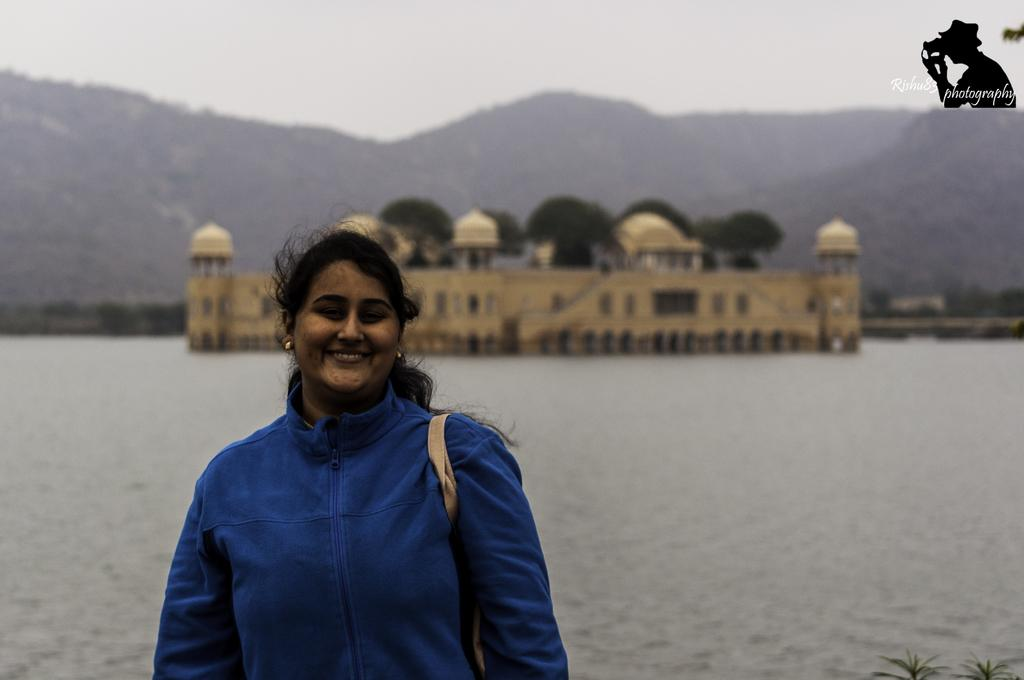Who is present in the image? There is a woman in the image. What is the woman's expression? The woman is smiling. What can be seen in the background of the image? There is water, at least one building, trees, and the sky visible in the background of the image. Can you describe the logo in the top right corner of the image? Unfortunately, the facts provided do not give any information about the logo. What might be the setting of the image based on the background? The image might be taken near a body of water, with buildings and trees in the background, suggesting an outdoor or waterfront location. What type of toys are being used in the feast depicted in the image? There is no feast or toys present in the image; it features a woman smiling with a background of water, buildings, trees, and the sky. 